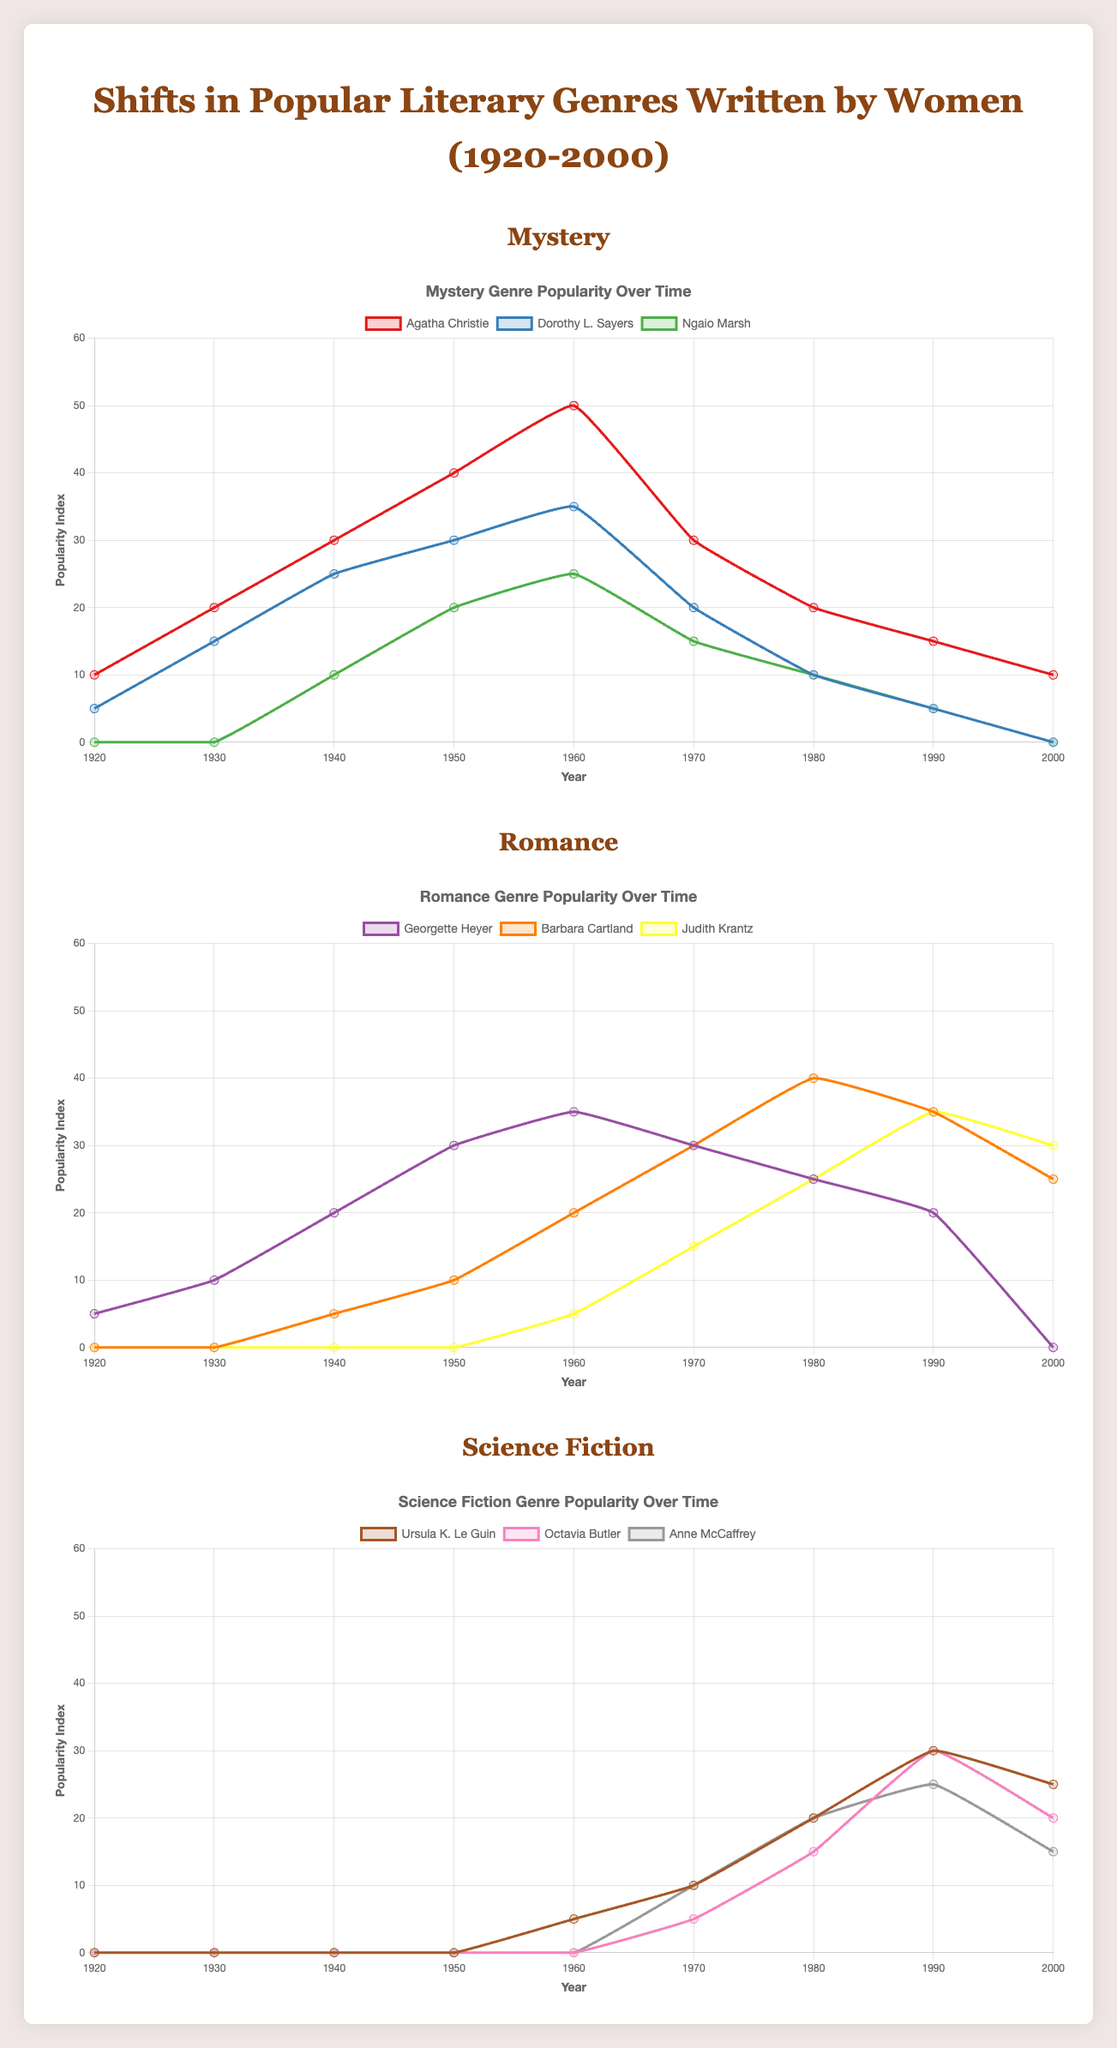Which mystery author had the highest popularity index in the 1960s? The figure shows the popularity data for Mystery authors, marked in different colors. By comparing the graph lines for 1960, Agatha Christie had the highest value of 50.
Answer: Agatha Christie How did the popularity of Science Fiction written by Ursula K. Le Guin change from the 1960s to the 1980s? Refer to the graph line for Ursula K. Le Guin. Her popularity index increased from 5 in the 1960s to 20 in the 1980s.
Answer: Increased Between 1950 and 1970, which Romance author saw the greatest increase in popularity? Look at the slopes of the lines for Georgette Heyer, Barbara Cartland, and Judith Krantz between 1950 and 1970. Barbara Cartland's line shows the greatest rise, from 10 to 30.
Answer: Barbara Cartland What was the popularity difference between Ngaio Marsh and Dorothy L. Sayers in 1950 for Mystery? Identify the values for both authors in 1950. Ngaio Marsh had 20, and Dorothy L. Sayers had 30. The difference is 30 - 20 = 10.
Answer: 10 Which year did Octavia Butler's popularity in Science Fiction reach its peak? Refer to the graph line for Octavia Butler and find the highest point. It peaks in 1990 with a value of 30.
Answer: 1990 What is the average popularity index of Barbara Cartland in the 1970s? Barbara Cartland's values in the 1970s are 30 (1970) and 40 (1980). The average is (30+40)/2 = 35.
Answer: 35 Compare the trend of Georgette Heyer and Judith Krantz in the 1990s. Look at the lines for Georgette Heyer and Judith Krantz from 1990 to 2000. Georgette Heyer's line decreases from 20 to 0, while Judith Krantz's line slightly decreases from 35 to 30.
Answer: Georgette Heyer declines more In Mystery, who was more popular in 1940, Agatha Christie or Dorothy L. Sayers, and by how much? Compare the values in the Mystery genre for 1940. Agatha Christie had 30, and Dorothy L. Sayers had 25. The difference is 30 - 25 = 5.
Answer: Agatha Christie by 5 Which author in Science Fiction had the lowest popularity in the 1960s, and what was the value? Check the values for Ursula K. Le Guin, Octavia Butler, and Anne McCaffrey in the 1960s. Octavia Butler had a value of 0, the lowest among them.
Answer: Octavia Butler with 0 